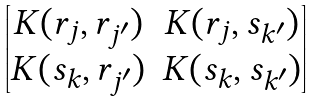<formula> <loc_0><loc_0><loc_500><loc_500>\begin{bmatrix} K ( r _ { j } , r _ { j ^ { \prime } } ) & K ( r _ { j } , s _ { k ^ { \prime } } ) \\ K ( s _ { k } , r _ { j ^ { \prime } } ) & K ( s _ { k } , s _ { k ^ { \prime } } ) \end{bmatrix}</formula> 